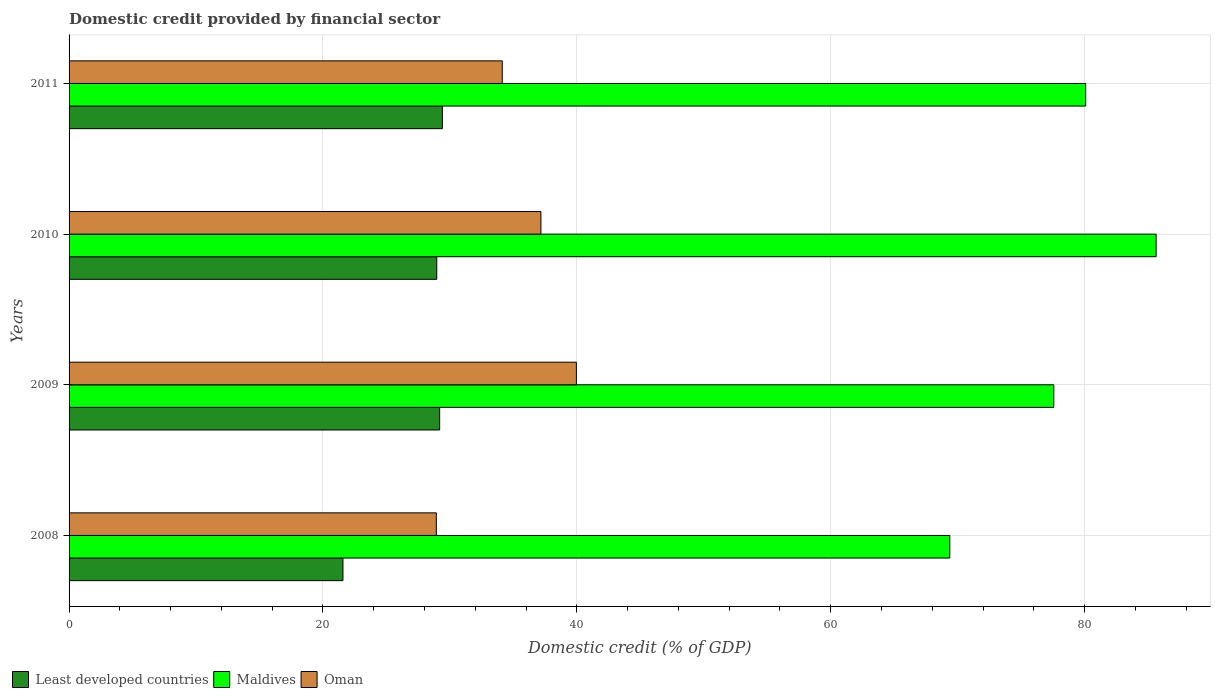How many different coloured bars are there?
Your answer should be compact. 3. How many groups of bars are there?
Keep it short and to the point. 4. Are the number of bars per tick equal to the number of legend labels?
Offer a terse response. Yes. Are the number of bars on each tick of the Y-axis equal?
Give a very brief answer. Yes. How many bars are there on the 3rd tick from the top?
Make the answer very short. 3. What is the label of the 3rd group of bars from the top?
Ensure brevity in your answer.  2009. In how many cases, is the number of bars for a given year not equal to the number of legend labels?
Make the answer very short. 0. What is the domestic credit in Least developed countries in 2011?
Your answer should be very brief. 29.41. Across all years, what is the maximum domestic credit in Least developed countries?
Offer a terse response. 29.41. Across all years, what is the minimum domestic credit in Maldives?
Ensure brevity in your answer.  69.38. In which year was the domestic credit in Maldives maximum?
Your answer should be compact. 2010. In which year was the domestic credit in Least developed countries minimum?
Your answer should be compact. 2008. What is the total domestic credit in Oman in the graph?
Your answer should be compact. 140.2. What is the difference between the domestic credit in Oman in 2009 and that in 2011?
Your answer should be compact. 5.84. What is the difference between the domestic credit in Maldives in 2010 and the domestic credit in Least developed countries in 2008?
Ensure brevity in your answer.  64.06. What is the average domestic credit in Oman per year?
Provide a short and direct response. 35.05. In the year 2011, what is the difference between the domestic credit in Oman and domestic credit in Maldives?
Make the answer very short. -45.96. What is the ratio of the domestic credit in Maldives in 2008 to that in 2010?
Your answer should be very brief. 0.81. What is the difference between the highest and the second highest domestic credit in Least developed countries?
Provide a succinct answer. 0.21. What is the difference between the highest and the lowest domestic credit in Least developed countries?
Provide a short and direct response. 7.83. What does the 2nd bar from the top in 2010 represents?
Ensure brevity in your answer.  Maldives. What does the 1st bar from the bottom in 2008 represents?
Provide a succinct answer. Least developed countries. Is it the case that in every year, the sum of the domestic credit in Oman and domestic credit in Least developed countries is greater than the domestic credit in Maldives?
Provide a short and direct response. No. How many bars are there?
Ensure brevity in your answer.  12. Are all the bars in the graph horizontal?
Provide a succinct answer. Yes. Where does the legend appear in the graph?
Provide a succinct answer. Bottom left. How many legend labels are there?
Give a very brief answer. 3. How are the legend labels stacked?
Your answer should be compact. Horizontal. What is the title of the graph?
Your answer should be very brief. Domestic credit provided by financial sector. Does "Qatar" appear as one of the legend labels in the graph?
Your answer should be very brief. No. What is the label or title of the X-axis?
Provide a succinct answer. Domestic credit (% of GDP). What is the Domestic credit (% of GDP) in Least developed countries in 2008?
Provide a succinct answer. 21.58. What is the Domestic credit (% of GDP) of Maldives in 2008?
Your response must be concise. 69.38. What is the Domestic credit (% of GDP) in Oman in 2008?
Give a very brief answer. 28.93. What is the Domestic credit (% of GDP) in Least developed countries in 2009?
Offer a terse response. 29.19. What is the Domestic credit (% of GDP) of Maldives in 2009?
Your answer should be very brief. 77.58. What is the Domestic credit (% of GDP) of Oman in 2009?
Make the answer very short. 39.97. What is the Domestic credit (% of GDP) in Least developed countries in 2010?
Your answer should be compact. 28.97. What is the Domestic credit (% of GDP) in Maldives in 2010?
Provide a short and direct response. 85.64. What is the Domestic credit (% of GDP) in Oman in 2010?
Your answer should be very brief. 37.17. What is the Domestic credit (% of GDP) of Least developed countries in 2011?
Ensure brevity in your answer.  29.41. What is the Domestic credit (% of GDP) of Maldives in 2011?
Offer a terse response. 80.09. What is the Domestic credit (% of GDP) in Oman in 2011?
Give a very brief answer. 34.13. Across all years, what is the maximum Domestic credit (% of GDP) of Least developed countries?
Your answer should be compact. 29.41. Across all years, what is the maximum Domestic credit (% of GDP) of Maldives?
Provide a succinct answer. 85.64. Across all years, what is the maximum Domestic credit (% of GDP) in Oman?
Your answer should be very brief. 39.97. Across all years, what is the minimum Domestic credit (% of GDP) of Least developed countries?
Keep it short and to the point. 21.58. Across all years, what is the minimum Domestic credit (% of GDP) of Maldives?
Ensure brevity in your answer.  69.38. Across all years, what is the minimum Domestic credit (% of GDP) of Oman?
Provide a succinct answer. 28.93. What is the total Domestic credit (% of GDP) of Least developed countries in the graph?
Provide a short and direct response. 109.15. What is the total Domestic credit (% of GDP) of Maldives in the graph?
Your answer should be compact. 312.69. What is the total Domestic credit (% of GDP) in Oman in the graph?
Provide a short and direct response. 140.2. What is the difference between the Domestic credit (% of GDP) of Least developed countries in 2008 and that in 2009?
Make the answer very short. -7.62. What is the difference between the Domestic credit (% of GDP) of Maldives in 2008 and that in 2009?
Your answer should be compact. -8.19. What is the difference between the Domestic credit (% of GDP) of Oman in 2008 and that in 2009?
Your answer should be compact. -11.03. What is the difference between the Domestic credit (% of GDP) in Least developed countries in 2008 and that in 2010?
Offer a terse response. -7.39. What is the difference between the Domestic credit (% of GDP) of Maldives in 2008 and that in 2010?
Keep it short and to the point. -16.26. What is the difference between the Domestic credit (% of GDP) in Oman in 2008 and that in 2010?
Your response must be concise. -8.24. What is the difference between the Domestic credit (% of GDP) of Least developed countries in 2008 and that in 2011?
Keep it short and to the point. -7.83. What is the difference between the Domestic credit (% of GDP) in Maldives in 2008 and that in 2011?
Your answer should be compact. -10.71. What is the difference between the Domestic credit (% of GDP) of Oman in 2008 and that in 2011?
Make the answer very short. -5.19. What is the difference between the Domestic credit (% of GDP) in Least developed countries in 2009 and that in 2010?
Provide a succinct answer. 0.23. What is the difference between the Domestic credit (% of GDP) in Maldives in 2009 and that in 2010?
Give a very brief answer. -8.06. What is the difference between the Domestic credit (% of GDP) of Oman in 2009 and that in 2010?
Provide a succinct answer. 2.8. What is the difference between the Domestic credit (% of GDP) of Least developed countries in 2009 and that in 2011?
Make the answer very short. -0.21. What is the difference between the Domestic credit (% of GDP) in Maldives in 2009 and that in 2011?
Offer a very short reply. -2.51. What is the difference between the Domestic credit (% of GDP) in Oman in 2009 and that in 2011?
Give a very brief answer. 5.84. What is the difference between the Domestic credit (% of GDP) in Least developed countries in 2010 and that in 2011?
Your response must be concise. -0.44. What is the difference between the Domestic credit (% of GDP) in Maldives in 2010 and that in 2011?
Your answer should be very brief. 5.55. What is the difference between the Domestic credit (% of GDP) in Oman in 2010 and that in 2011?
Offer a very short reply. 3.05. What is the difference between the Domestic credit (% of GDP) of Least developed countries in 2008 and the Domestic credit (% of GDP) of Maldives in 2009?
Provide a short and direct response. -56. What is the difference between the Domestic credit (% of GDP) in Least developed countries in 2008 and the Domestic credit (% of GDP) in Oman in 2009?
Keep it short and to the point. -18.39. What is the difference between the Domestic credit (% of GDP) of Maldives in 2008 and the Domestic credit (% of GDP) of Oman in 2009?
Your answer should be very brief. 29.42. What is the difference between the Domestic credit (% of GDP) of Least developed countries in 2008 and the Domestic credit (% of GDP) of Maldives in 2010?
Your answer should be compact. -64.06. What is the difference between the Domestic credit (% of GDP) in Least developed countries in 2008 and the Domestic credit (% of GDP) in Oman in 2010?
Make the answer very short. -15.59. What is the difference between the Domestic credit (% of GDP) of Maldives in 2008 and the Domestic credit (% of GDP) of Oman in 2010?
Your answer should be compact. 32.21. What is the difference between the Domestic credit (% of GDP) in Least developed countries in 2008 and the Domestic credit (% of GDP) in Maldives in 2011?
Offer a very short reply. -58.51. What is the difference between the Domestic credit (% of GDP) of Least developed countries in 2008 and the Domestic credit (% of GDP) of Oman in 2011?
Give a very brief answer. -12.55. What is the difference between the Domestic credit (% of GDP) of Maldives in 2008 and the Domestic credit (% of GDP) of Oman in 2011?
Make the answer very short. 35.26. What is the difference between the Domestic credit (% of GDP) in Least developed countries in 2009 and the Domestic credit (% of GDP) in Maldives in 2010?
Make the answer very short. -56.44. What is the difference between the Domestic credit (% of GDP) of Least developed countries in 2009 and the Domestic credit (% of GDP) of Oman in 2010?
Provide a short and direct response. -7.98. What is the difference between the Domestic credit (% of GDP) in Maldives in 2009 and the Domestic credit (% of GDP) in Oman in 2010?
Give a very brief answer. 40.41. What is the difference between the Domestic credit (% of GDP) of Least developed countries in 2009 and the Domestic credit (% of GDP) of Maldives in 2011?
Give a very brief answer. -50.89. What is the difference between the Domestic credit (% of GDP) of Least developed countries in 2009 and the Domestic credit (% of GDP) of Oman in 2011?
Ensure brevity in your answer.  -4.93. What is the difference between the Domestic credit (% of GDP) of Maldives in 2009 and the Domestic credit (% of GDP) of Oman in 2011?
Offer a terse response. 43.45. What is the difference between the Domestic credit (% of GDP) of Least developed countries in 2010 and the Domestic credit (% of GDP) of Maldives in 2011?
Offer a very short reply. -51.12. What is the difference between the Domestic credit (% of GDP) in Least developed countries in 2010 and the Domestic credit (% of GDP) in Oman in 2011?
Provide a succinct answer. -5.16. What is the difference between the Domestic credit (% of GDP) in Maldives in 2010 and the Domestic credit (% of GDP) in Oman in 2011?
Keep it short and to the point. 51.51. What is the average Domestic credit (% of GDP) of Least developed countries per year?
Make the answer very short. 27.29. What is the average Domestic credit (% of GDP) in Maldives per year?
Keep it short and to the point. 78.17. What is the average Domestic credit (% of GDP) in Oman per year?
Your answer should be very brief. 35.05. In the year 2008, what is the difference between the Domestic credit (% of GDP) of Least developed countries and Domestic credit (% of GDP) of Maldives?
Give a very brief answer. -47.81. In the year 2008, what is the difference between the Domestic credit (% of GDP) of Least developed countries and Domestic credit (% of GDP) of Oman?
Offer a very short reply. -7.36. In the year 2008, what is the difference between the Domestic credit (% of GDP) in Maldives and Domestic credit (% of GDP) in Oman?
Ensure brevity in your answer.  40.45. In the year 2009, what is the difference between the Domestic credit (% of GDP) of Least developed countries and Domestic credit (% of GDP) of Maldives?
Your answer should be very brief. -48.38. In the year 2009, what is the difference between the Domestic credit (% of GDP) in Least developed countries and Domestic credit (% of GDP) in Oman?
Your response must be concise. -10.77. In the year 2009, what is the difference between the Domestic credit (% of GDP) of Maldives and Domestic credit (% of GDP) of Oman?
Provide a succinct answer. 37.61. In the year 2010, what is the difference between the Domestic credit (% of GDP) of Least developed countries and Domestic credit (% of GDP) of Maldives?
Your answer should be very brief. -56.67. In the year 2010, what is the difference between the Domestic credit (% of GDP) in Least developed countries and Domestic credit (% of GDP) in Oman?
Your answer should be very brief. -8.2. In the year 2010, what is the difference between the Domestic credit (% of GDP) in Maldives and Domestic credit (% of GDP) in Oman?
Provide a succinct answer. 48.47. In the year 2011, what is the difference between the Domestic credit (% of GDP) of Least developed countries and Domestic credit (% of GDP) of Maldives?
Provide a succinct answer. -50.68. In the year 2011, what is the difference between the Domestic credit (% of GDP) in Least developed countries and Domestic credit (% of GDP) in Oman?
Your answer should be compact. -4.72. In the year 2011, what is the difference between the Domestic credit (% of GDP) of Maldives and Domestic credit (% of GDP) of Oman?
Provide a short and direct response. 45.96. What is the ratio of the Domestic credit (% of GDP) of Least developed countries in 2008 to that in 2009?
Provide a short and direct response. 0.74. What is the ratio of the Domestic credit (% of GDP) of Maldives in 2008 to that in 2009?
Offer a terse response. 0.89. What is the ratio of the Domestic credit (% of GDP) in Oman in 2008 to that in 2009?
Your answer should be compact. 0.72. What is the ratio of the Domestic credit (% of GDP) of Least developed countries in 2008 to that in 2010?
Keep it short and to the point. 0.74. What is the ratio of the Domestic credit (% of GDP) of Maldives in 2008 to that in 2010?
Keep it short and to the point. 0.81. What is the ratio of the Domestic credit (% of GDP) of Oman in 2008 to that in 2010?
Provide a succinct answer. 0.78. What is the ratio of the Domestic credit (% of GDP) of Least developed countries in 2008 to that in 2011?
Ensure brevity in your answer.  0.73. What is the ratio of the Domestic credit (% of GDP) in Maldives in 2008 to that in 2011?
Your response must be concise. 0.87. What is the ratio of the Domestic credit (% of GDP) in Oman in 2008 to that in 2011?
Provide a short and direct response. 0.85. What is the ratio of the Domestic credit (% of GDP) of Maldives in 2009 to that in 2010?
Keep it short and to the point. 0.91. What is the ratio of the Domestic credit (% of GDP) in Oman in 2009 to that in 2010?
Your response must be concise. 1.08. What is the ratio of the Domestic credit (% of GDP) of Least developed countries in 2009 to that in 2011?
Keep it short and to the point. 0.99. What is the ratio of the Domestic credit (% of GDP) in Maldives in 2009 to that in 2011?
Provide a succinct answer. 0.97. What is the ratio of the Domestic credit (% of GDP) of Oman in 2009 to that in 2011?
Your response must be concise. 1.17. What is the ratio of the Domestic credit (% of GDP) of Maldives in 2010 to that in 2011?
Provide a short and direct response. 1.07. What is the ratio of the Domestic credit (% of GDP) of Oman in 2010 to that in 2011?
Give a very brief answer. 1.09. What is the difference between the highest and the second highest Domestic credit (% of GDP) of Least developed countries?
Your answer should be compact. 0.21. What is the difference between the highest and the second highest Domestic credit (% of GDP) in Maldives?
Keep it short and to the point. 5.55. What is the difference between the highest and the second highest Domestic credit (% of GDP) in Oman?
Offer a terse response. 2.8. What is the difference between the highest and the lowest Domestic credit (% of GDP) in Least developed countries?
Keep it short and to the point. 7.83. What is the difference between the highest and the lowest Domestic credit (% of GDP) of Maldives?
Your response must be concise. 16.26. What is the difference between the highest and the lowest Domestic credit (% of GDP) of Oman?
Provide a short and direct response. 11.03. 